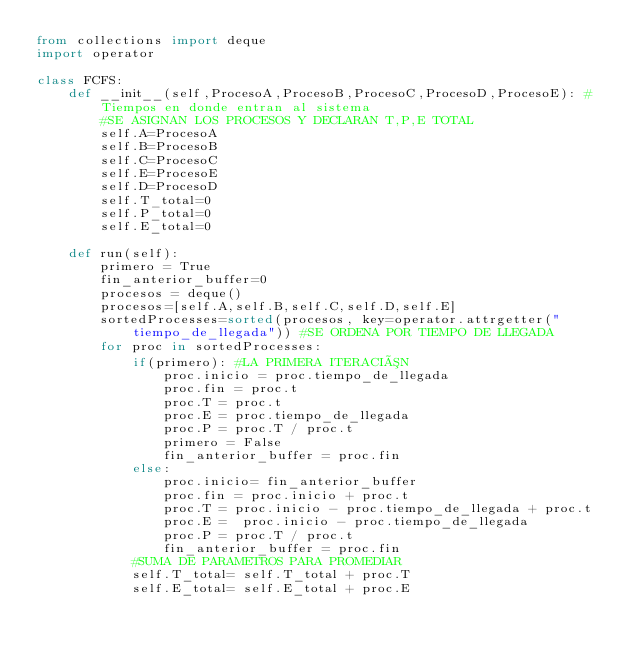<code> <loc_0><loc_0><loc_500><loc_500><_Python_>from collections import deque
import operator

class FCFS:
    def __init__(self,ProcesoA,ProcesoB,ProcesoC,ProcesoD,ProcesoE): #Tiempos en donde entran al sistema
        #SE ASIGNAN LOS PROCESOS Y DECLARAN T,P,E TOTAL
        self.A=ProcesoA
        self.B=ProcesoB
        self.C=ProcesoC
        self.E=ProcesoE
        self.D=ProcesoD
        self.T_total=0
        self.P_total=0
        self.E_total=0

    def run(self):
        primero = True
        fin_anterior_buffer=0
        procesos = deque()
        procesos=[self.A,self.B,self.C,self.D,self.E]
        sortedProcesses=sorted(procesos, key=operator.attrgetter("tiempo_de_llegada")) #SE ORDENA POR TIEMPO DE LLEGADA
        for proc in sortedProcesses:
            if(primero): #LA PRIMERA ITERACIÓN
                proc.inicio = proc.tiempo_de_llegada
                proc.fin = proc.t
                proc.T = proc.t
                proc.E = proc.tiempo_de_llegada
                proc.P = proc.T / proc.t
                primero = False
                fin_anterior_buffer = proc.fin
            else:
                proc.inicio= fin_anterior_buffer
                proc.fin = proc.inicio + proc.t
                proc.T = proc.inicio - proc.tiempo_de_llegada + proc.t
                proc.E =  proc.inicio - proc.tiempo_de_llegada
                proc.P = proc.T / proc.t
                fin_anterior_buffer = proc.fin
            #SUMA DE PARAMETROS PARA PROMEDIAR
            self.T_total= self.T_total + proc.T
            self.E_total= self.E_total + proc.E</code> 